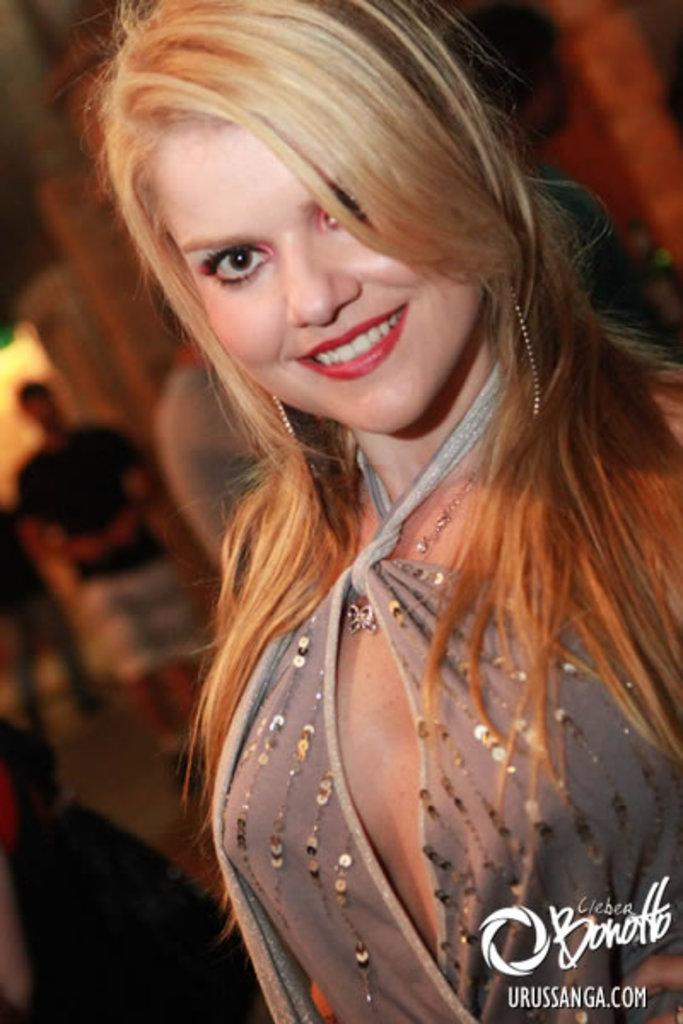Who is the main subject in the image? There is a woman in the image. What is the woman doing in the image? The woman is standing and smiling. Can you describe the people in the background of the image? There are people in the background of the image, but their specific actions or appearances are not mentioned in the provided facts. What type of brush is the woman using to paint the gate in the image? There is no gate or brush present in the image. 